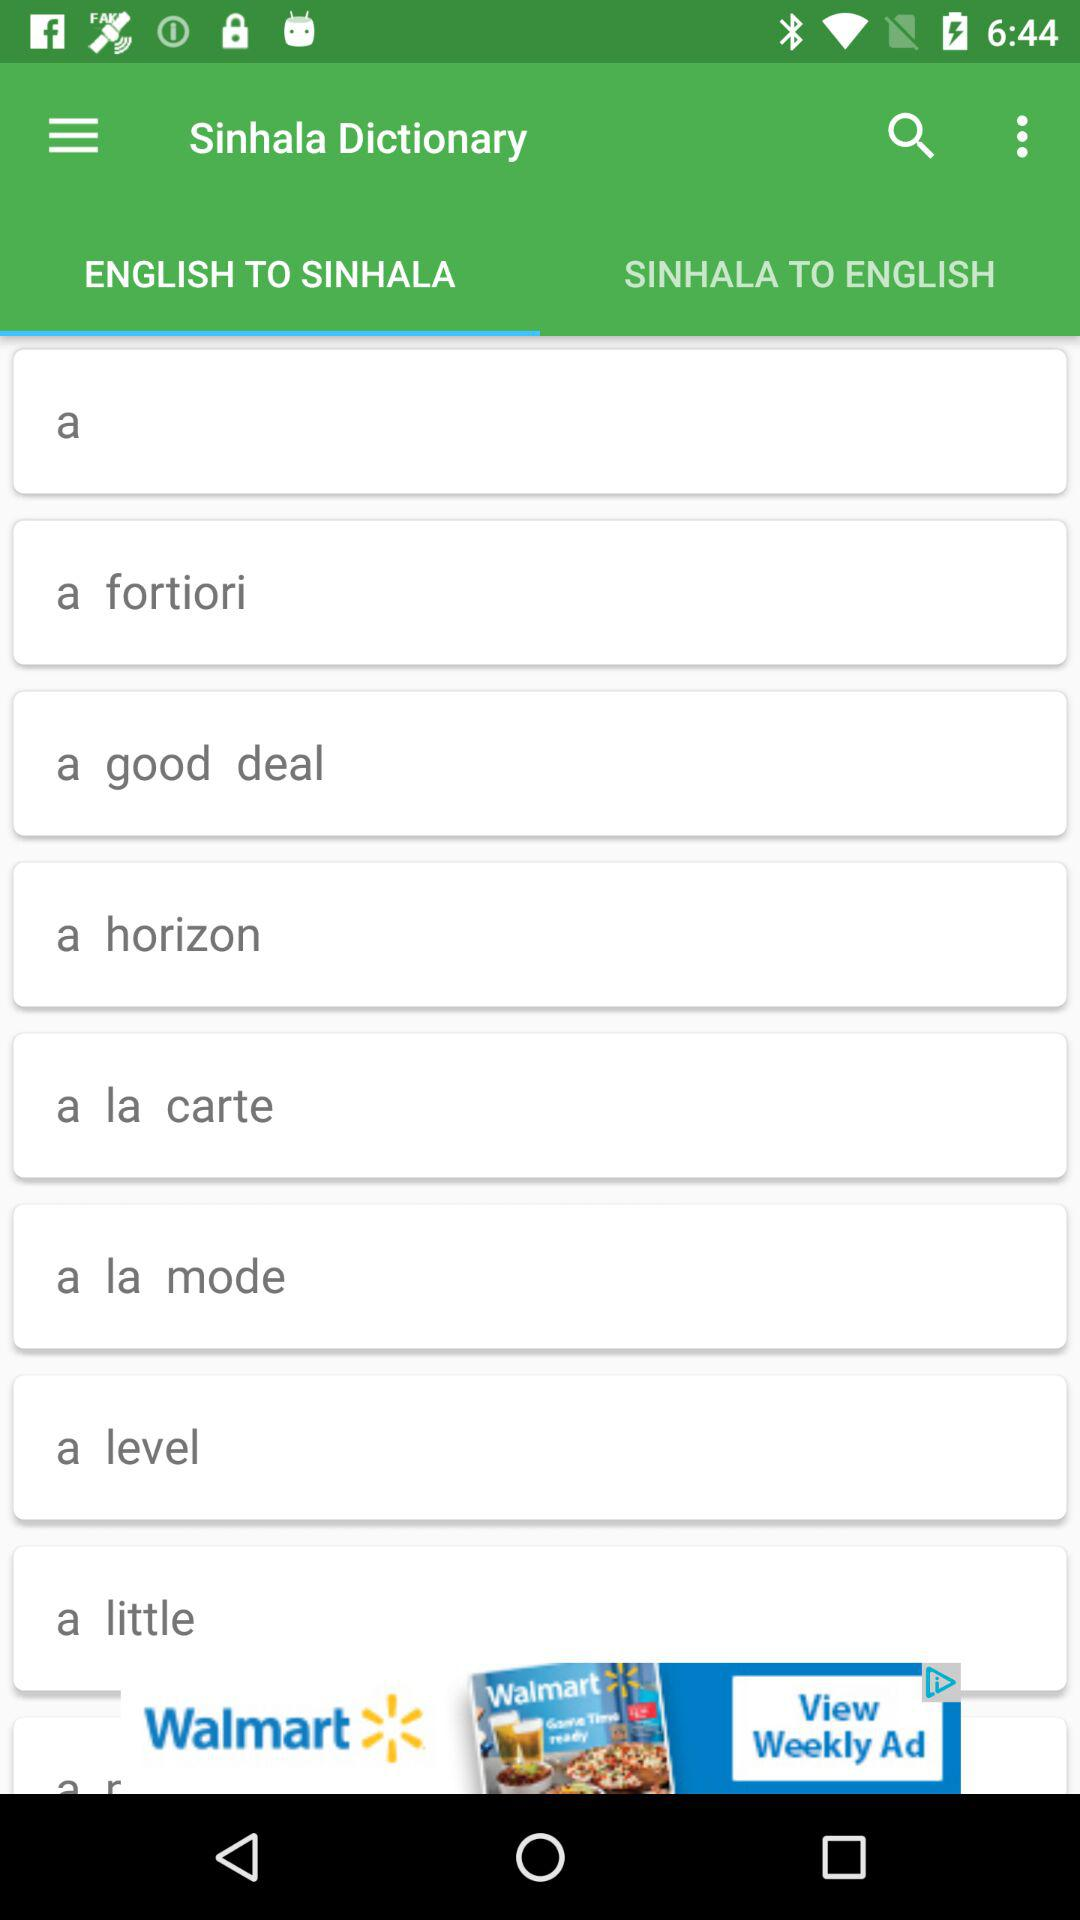Which tab is open? The opened tab is "ENGLISH TO SINHALA". 